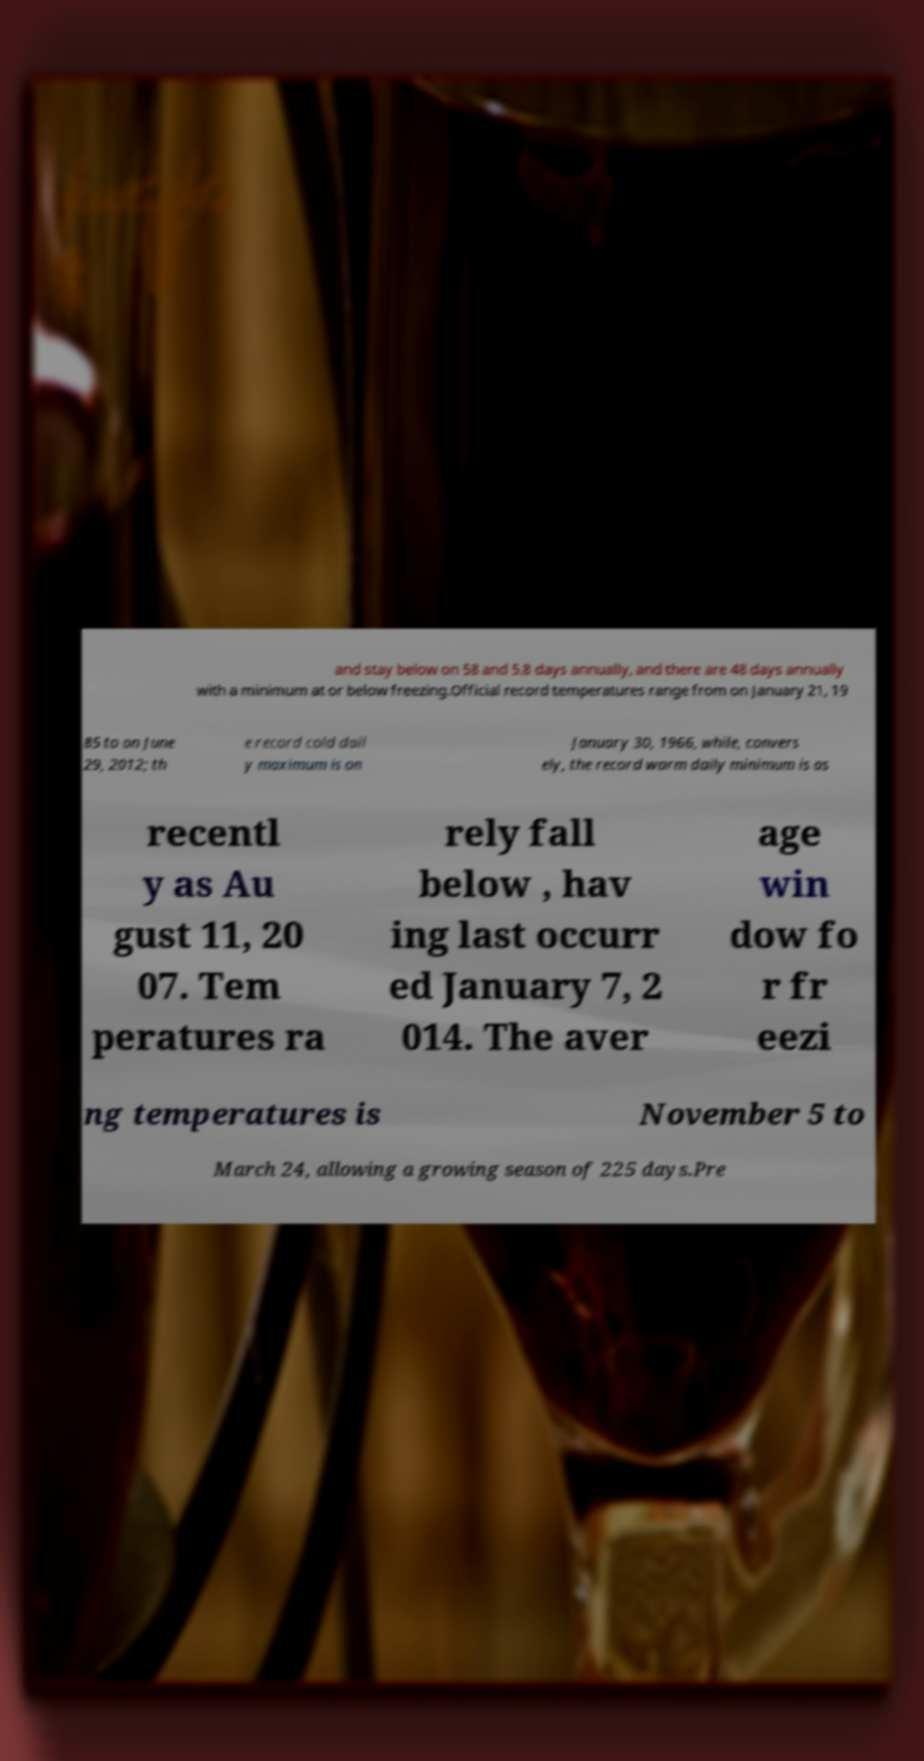Could you assist in decoding the text presented in this image and type it out clearly? and stay below on 58 and 5.8 days annually, and there are 48 days annually with a minimum at or below freezing.Official record temperatures range from on January 21, 19 85 to on June 29, 2012; th e record cold dail y maximum is on January 30, 1966, while, convers ely, the record warm daily minimum is as recentl y as Au gust 11, 20 07. Tem peratures ra rely fall below , hav ing last occurr ed January 7, 2 014. The aver age win dow fo r fr eezi ng temperatures is November 5 to March 24, allowing a growing season of 225 days.Pre 